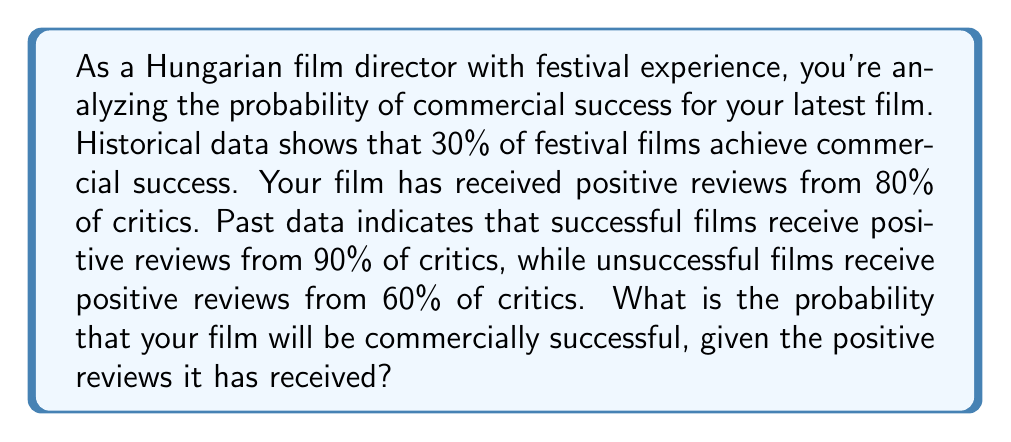Can you solve this math problem? Let's approach this problem using Bayesian inference:

1) Define our events:
   S: The film is commercially successful
   R: The film receives positive reviews from 80% of critics

2) Given probabilities:
   P(S) = 0.30 (prior probability of success)
   P(R|S) = 0.90 (probability of positive reviews given success)
   P(R|not S) = 0.60 (probability of positive reviews given no success)
   P(R) = 0.80 (our observed data)

3) We want to find P(S|R) using Bayes' theorem:

   $$P(S|R) = \frac{P(R|S) \cdot P(S)}{P(R)}$$

4) Calculate P(R) using the law of total probability:
   $$P(R) = P(R|S) \cdot P(S) + P(R|not S) \cdot P(not S)$$
   $$P(R) = 0.90 \cdot 0.30 + 0.60 \cdot 0.70 = 0.27 + 0.42 = 0.69$$

5) Now we can apply Bayes' theorem:

   $$P(S|R) = \frac{0.90 \cdot 0.30}{0.69} = \frac{0.27}{0.69} \approx 0.3913$$

6) Convert to a percentage:
   0.3913 * 100 ≈ 39.13%

Therefore, given the positive reviews, the probability of commercial success for your film is approximately 39.13%.
Answer: 39.13% 